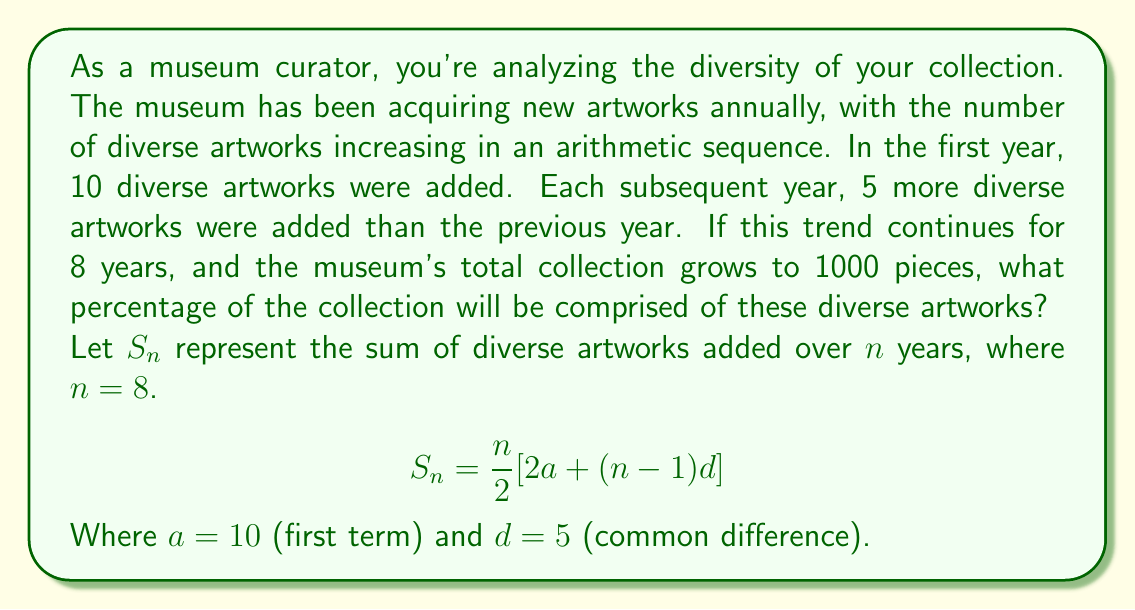What is the answer to this math problem? To solve this problem, we'll follow these steps:

1) First, let's calculate the total number of diverse artworks added over the 8 years using the arithmetic sequence sum formula:

   $$S_8 = \frac{8}{2}[2(10) + (8-1)5]$$
   $$S_8 = 4[20 + 35]$$
   $$S_8 = 4(55) = 220$$

2) So, 220 diverse artworks were added over the 8-year period.

3) We're told that the museum's total collection grows to 1000 pieces.

4) To calculate the percentage, we use the formula:

   $$\text{Percentage} = \frac{\text{Part}}{\text{Whole}} \times 100\%$$

5) In this case:
   $$\text{Percentage} = \frac{220}{1000} \times 100\%$$
   $$\text{Percentage} = 0.22 \times 100\% = 22\%$$
Answer: 22% 